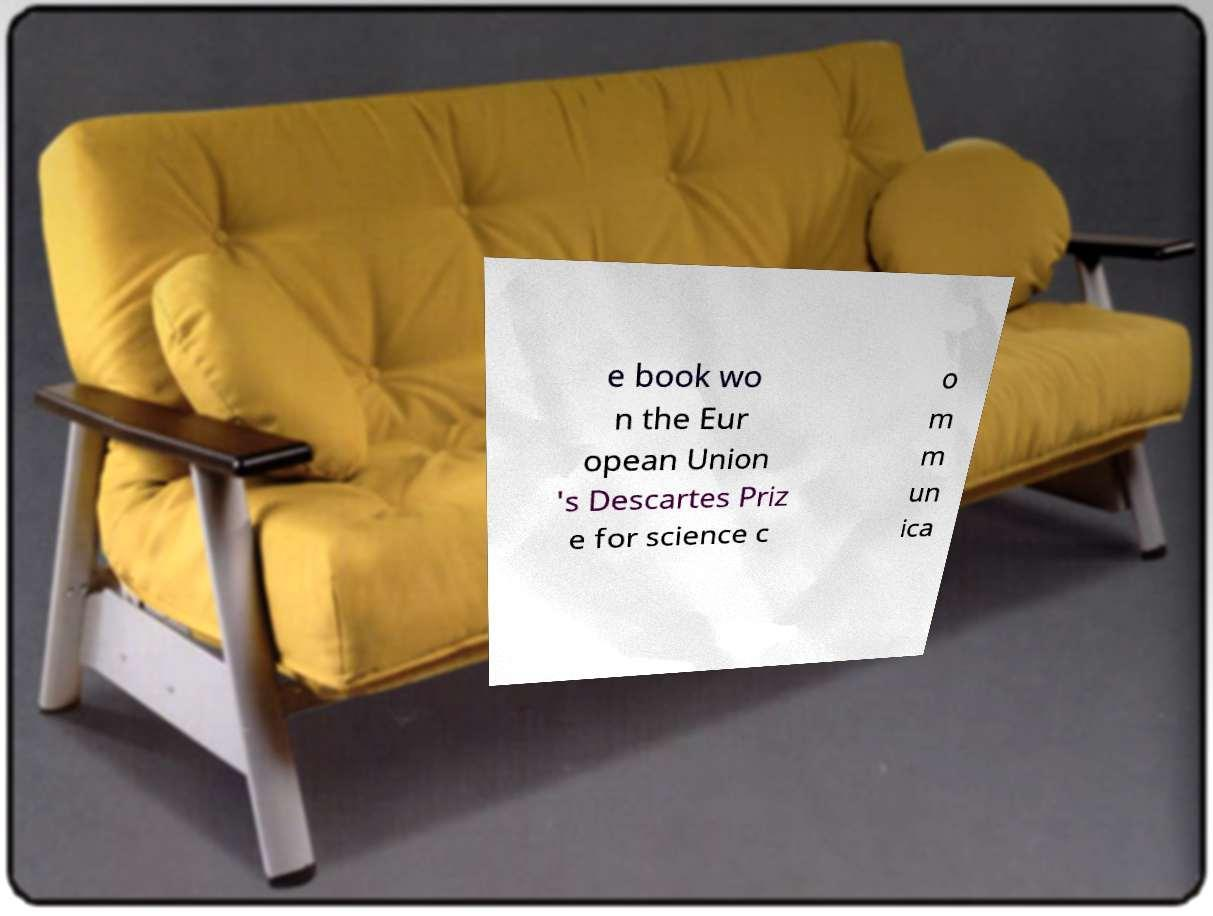Can you read and provide the text displayed in the image?This photo seems to have some interesting text. Can you extract and type it out for me? e book wo n the Eur opean Union 's Descartes Priz e for science c o m m un ica 